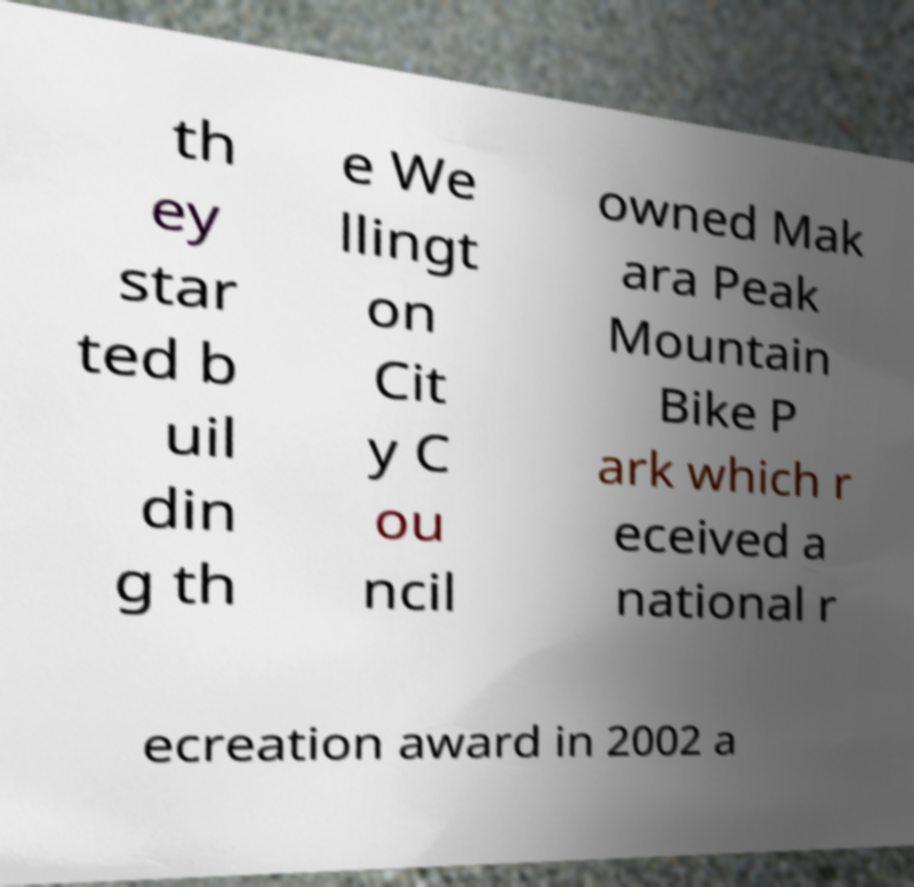There's text embedded in this image that I need extracted. Can you transcribe it verbatim? th ey star ted b uil din g th e We llingt on Cit y C ou ncil owned Mak ara Peak Mountain Bike P ark which r eceived a national r ecreation award in 2002 a 